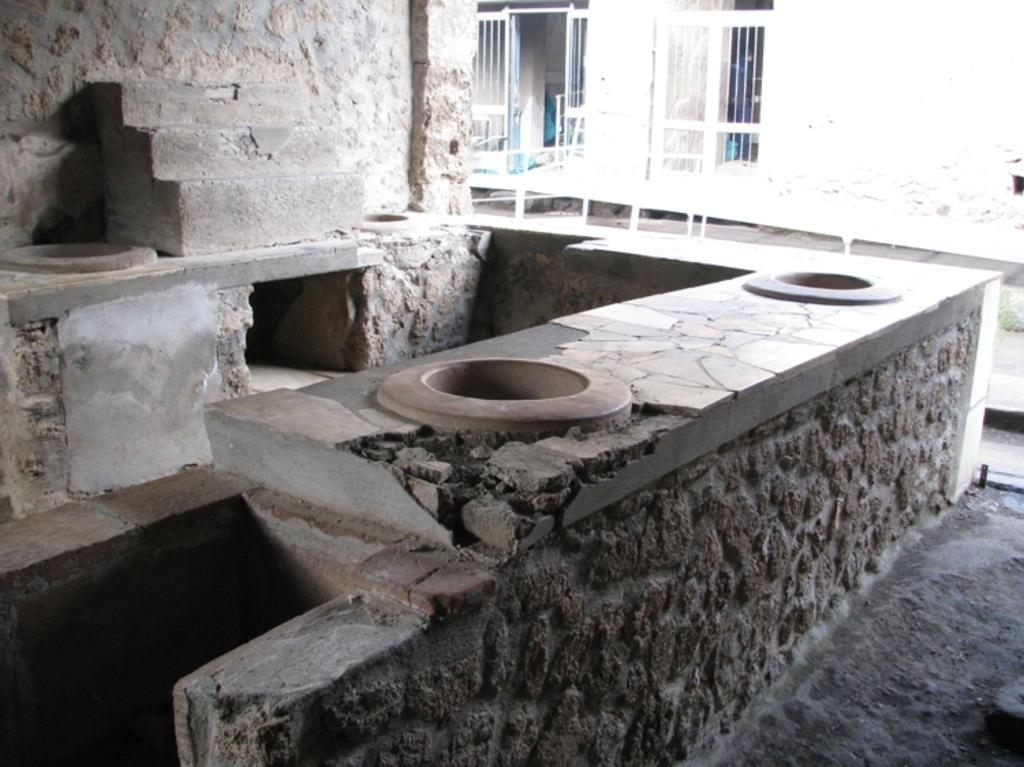What architectural feature is present in the image? There are steps in the image. What other structural element can be seen in the image? There is a wall in the image. What surface is visible beneath the steps and wall? There is a floor in the image. What can be seen in the background of the image? There are windows visible in the background of the image. Can you tell me how many snails are crawling on the steps in the image? There are no snails present in the image; it only features steps, a wall, a floor, and windows in the background. What type of snake can be seen slithering on the floor in the image? There are no snakes present in the image; it only features steps, a wall, a floor, and windows in the background. 